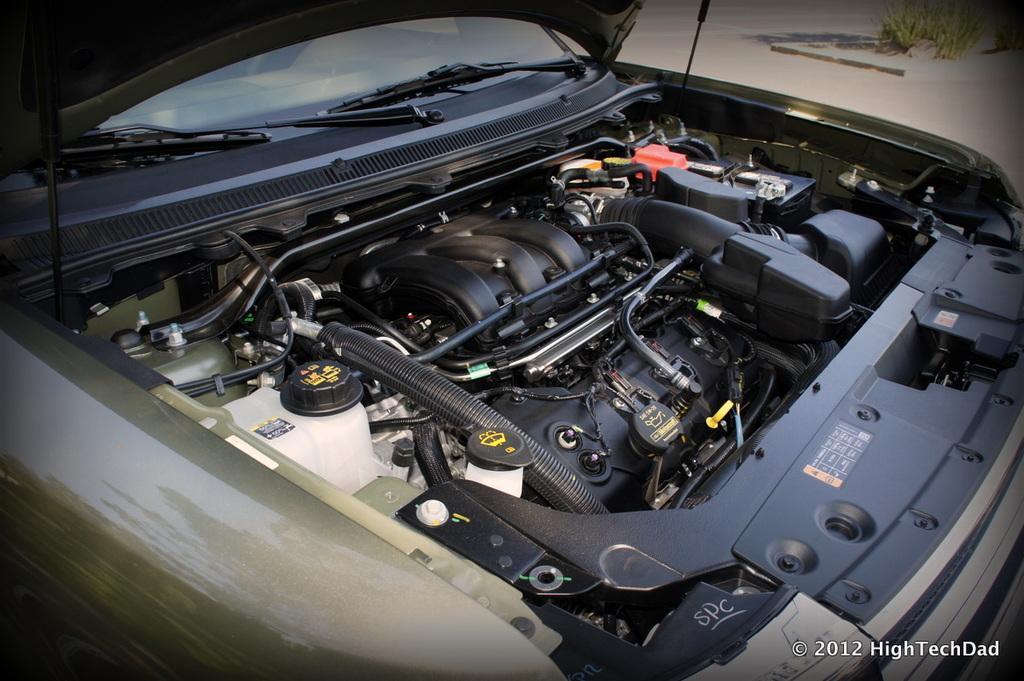Please provide a concise description of this image. In this picture there is a engine of a vehicle which has few objects in it. 